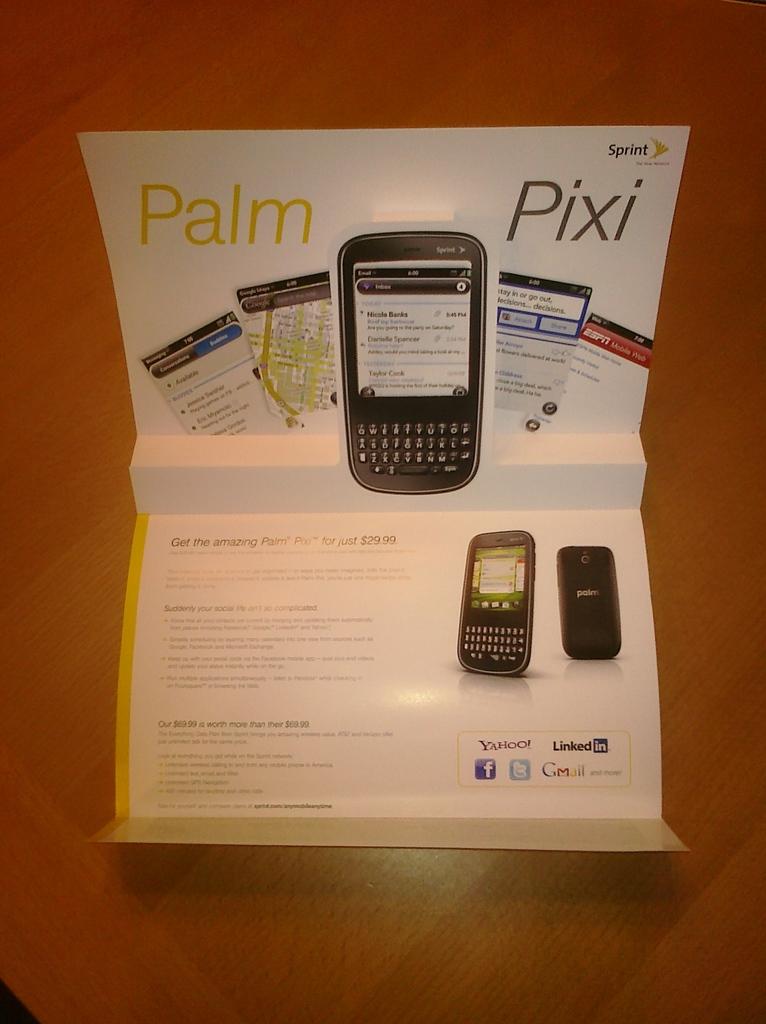What is written on the top phone face?
Your answer should be compact. Sprint. 